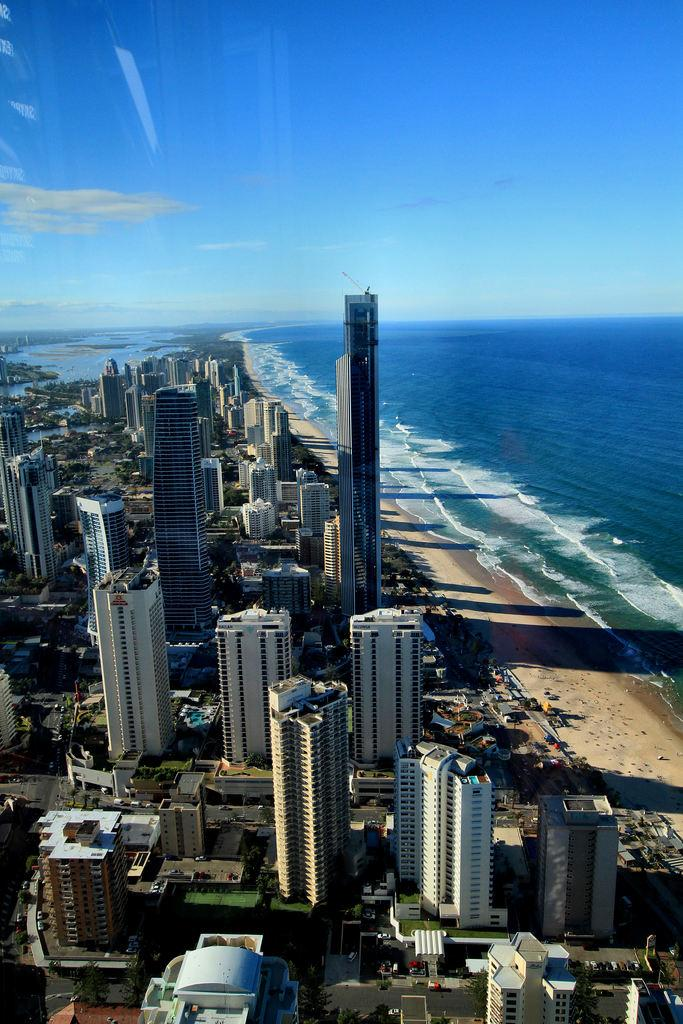What type of image is this? The image is a top view of a city. What structures can be seen in the image? There are buildings visible in the image. What natural element is visible in the image? There is water visible in the image. Can you see any bees flying around the buildings in the image? There are no bees visible in the image; it is a top view of a city with buildings and water. Is there a room with an umbrella hanging in it in the image? The image is a top view of a city, and there is no room or umbrella visible in the image. 